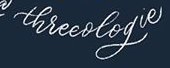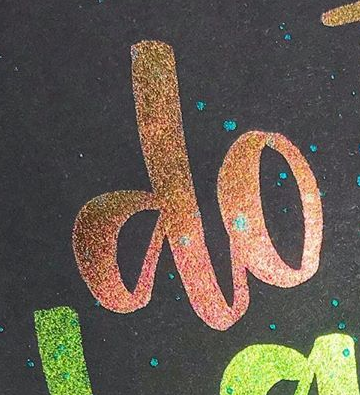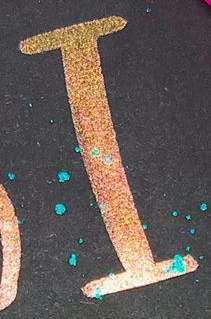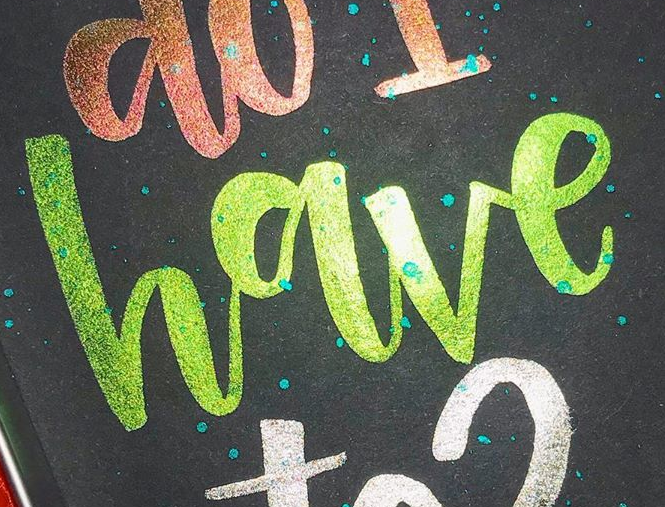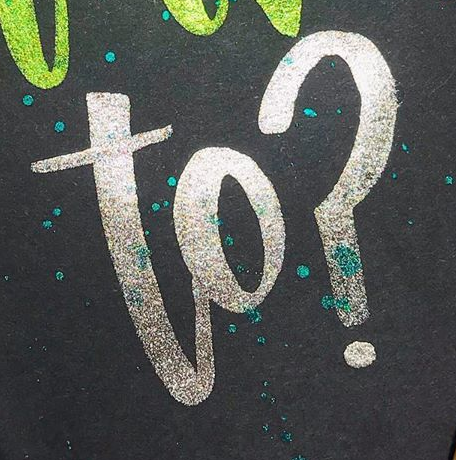Transcribe the words shown in these images in order, separated by a semicolon. threeologie; do; I; have; to? 